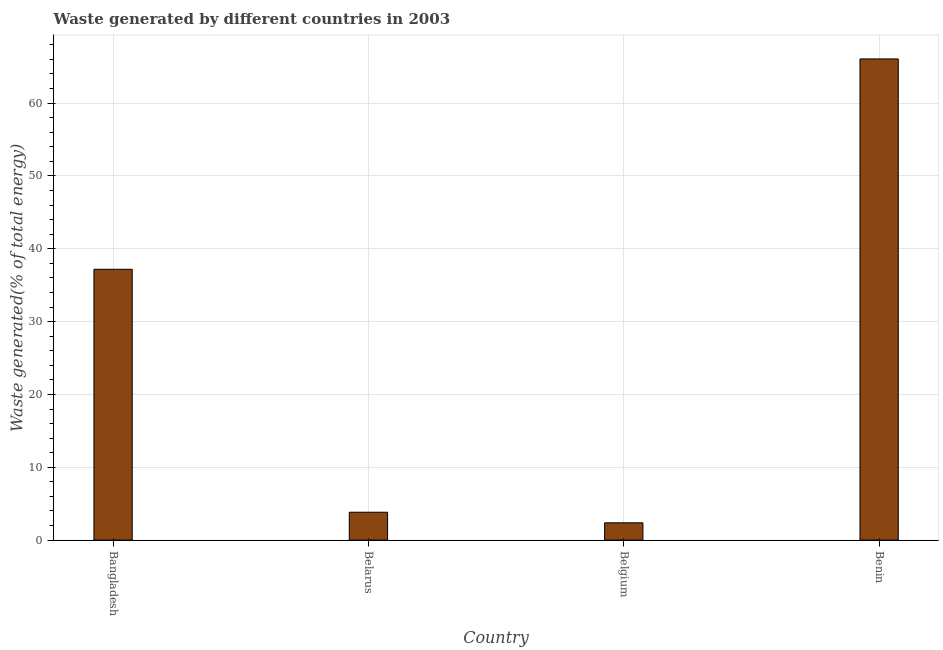Does the graph contain grids?
Your answer should be compact. Yes. What is the title of the graph?
Ensure brevity in your answer.  Waste generated by different countries in 2003. What is the label or title of the Y-axis?
Make the answer very short. Waste generated(% of total energy). What is the amount of waste generated in Belarus?
Your answer should be very brief. 3.83. Across all countries, what is the maximum amount of waste generated?
Keep it short and to the point. 66.07. Across all countries, what is the minimum amount of waste generated?
Offer a terse response. 2.37. In which country was the amount of waste generated maximum?
Your answer should be very brief. Benin. What is the sum of the amount of waste generated?
Offer a terse response. 109.45. What is the difference between the amount of waste generated in Belarus and Belgium?
Provide a short and direct response. 1.45. What is the average amount of waste generated per country?
Offer a terse response. 27.36. What is the median amount of waste generated?
Ensure brevity in your answer.  20.5. What is the ratio of the amount of waste generated in Belarus to that in Belgium?
Offer a terse response. 1.61. Is the amount of waste generated in Belgium less than that in Benin?
Make the answer very short. Yes. Is the difference between the amount of waste generated in Belarus and Belgium greater than the difference between any two countries?
Provide a short and direct response. No. What is the difference between the highest and the second highest amount of waste generated?
Give a very brief answer. 28.88. What is the difference between the highest and the lowest amount of waste generated?
Keep it short and to the point. 63.69. In how many countries, is the amount of waste generated greater than the average amount of waste generated taken over all countries?
Keep it short and to the point. 2. How many bars are there?
Give a very brief answer. 4. How many countries are there in the graph?
Your answer should be very brief. 4. What is the difference between two consecutive major ticks on the Y-axis?
Your response must be concise. 10. Are the values on the major ticks of Y-axis written in scientific E-notation?
Provide a succinct answer. No. What is the Waste generated(% of total energy) in Bangladesh?
Offer a very short reply. 37.18. What is the Waste generated(% of total energy) of Belarus?
Offer a terse response. 3.83. What is the Waste generated(% of total energy) in Belgium?
Provide a short and direct response. 2.37. What is the Waste generated(% of total energy) in Benin?
Your answer should be very brief. 66.07. What is the difference between the Waste generated(% of total energy) in Bangladesh and Belarus?
Your answer should be very brief. 33.36. What is the difference between the Waste generated(% of total energy) in Bangladesh and Belgium?
Offer a terse response. 34.81. What is the difference between the Waste generated(% of total energy) in Bangladesh and Benin?
Your response must be concise. -28.88. What is the difference between the Waste generated(% of total energy) in Belarus and Belgium?
Your answer should be compact. 1.45. What is the difference between the Waste generated(% of total energy) in Belarus and Benin?
Offer a very short reply. -62.24. What is the difference between the Waste generated(% of total energy) in Belgium and Benin?
Your response must be concise. -63.69. What is the ratio of the Waste generated(% of total energy) in Bangladesh to that in Belarus?
Keep it short and to the point. 9.72. What is the ratio of the Waste generated(% of total energy) in Bangladesh to that in Belgium?
Offer a terse response. 15.67. What is the ratio of the Waste generated(% of total energy) in Bangladesh to that in Benin?
Offer a very short reply. 0.56. What is the ratio of the Waste generated(% of total energy) in Belarus to that in Belgium?
Offer a very short reply. 1.61. What is the ratio of the Waste generated(% of total energy) in Belarus to that in Benin?
Offer a terse response. 0.06. What is the ratio of the Waste generated(% of total energy) in Belgium to that in Benin?
Offer a terse response. 0.04. 